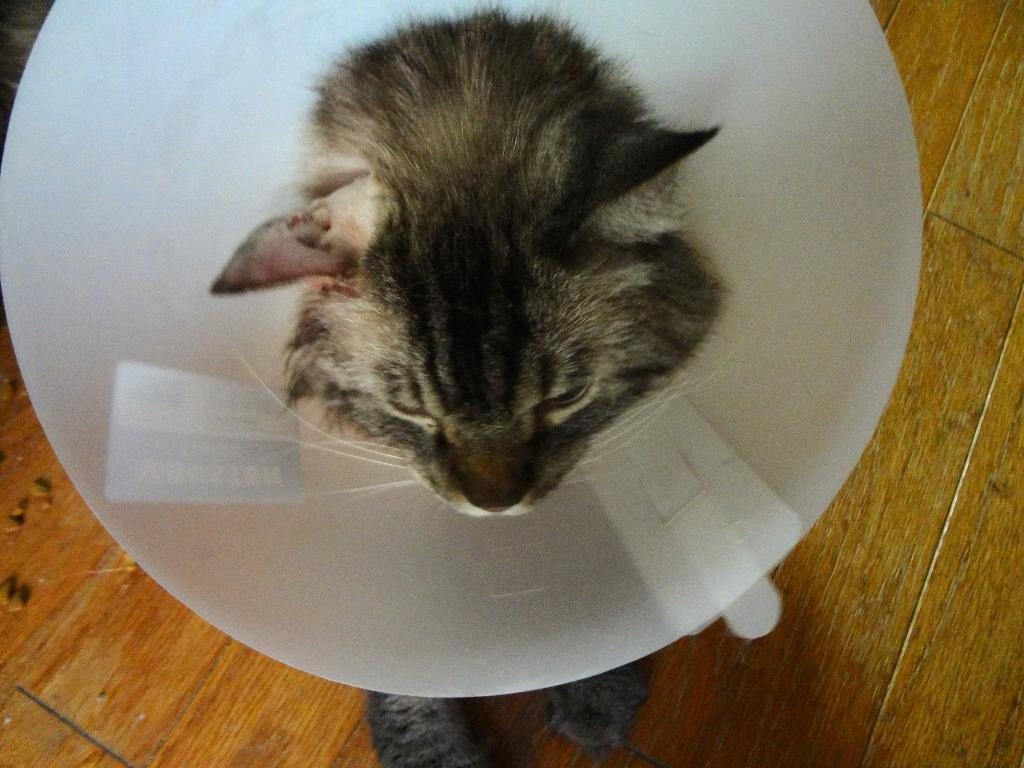What is the main subject of the image? There is a cat in the center of the image. What is unusual about the cat's appearance? The cat has a funnel on its head. What is located at the bottom of the image? There is a table at the bottom of the image. How many goats can be seen interacting with the cat in the image? There are no goats present in the image. What type of rabbit is sitting next to the cat in the image? There are no rabbits present in the image. 